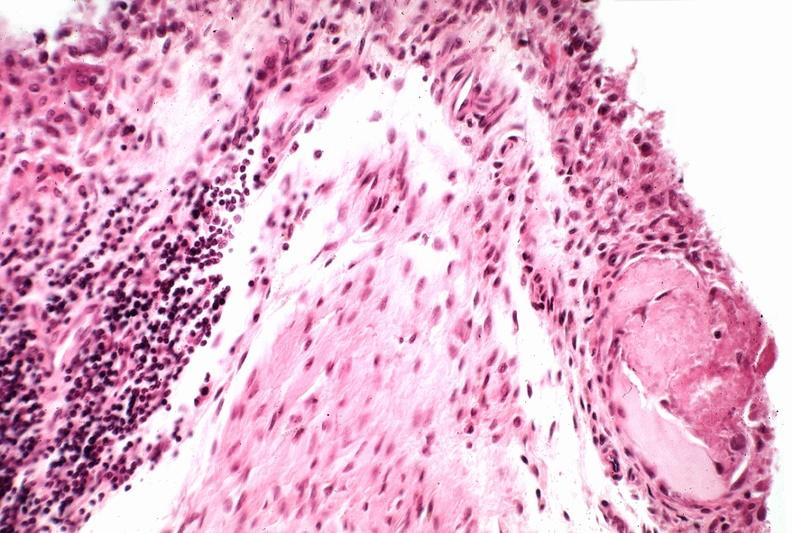what does this image show?
Answer the question using a single word or phrase. Synovial proliferation 